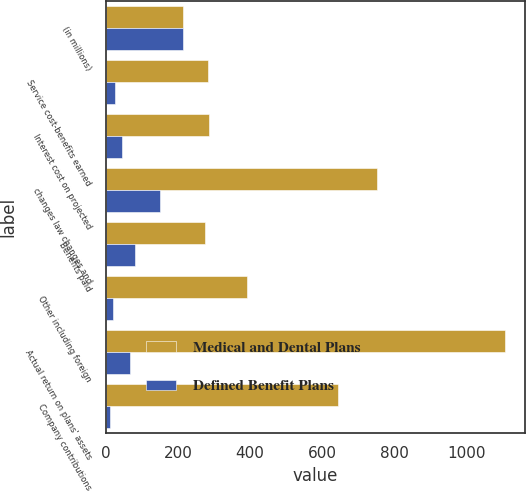Convert chart. <chart><loc_0><loc_0><loc_500><loc_500><stacked_bar_chart><ecel><fcel>(in millions)<fcel>Service cost-benefits earned<fcel>Interest cost on projected<fcel>changes law changes and<fcel>Benefits paid<fcel>Other including foreign<fcel>Actual return on plans' assets<fcel>Company contributions<nl><fcel>Medical and Dental Plans<fcel>212.5<fcel>283<fcel>287<fcel>752<fcel>276<fcel>390<fcel>1107<fcel>645<nl><fcel>Defined Benefit Plans<fcel>212.5<fcel>25<fcel>45<fcel>149<fcel>80<fcel>20<fcel>65<fcel>12<nl></chart> 